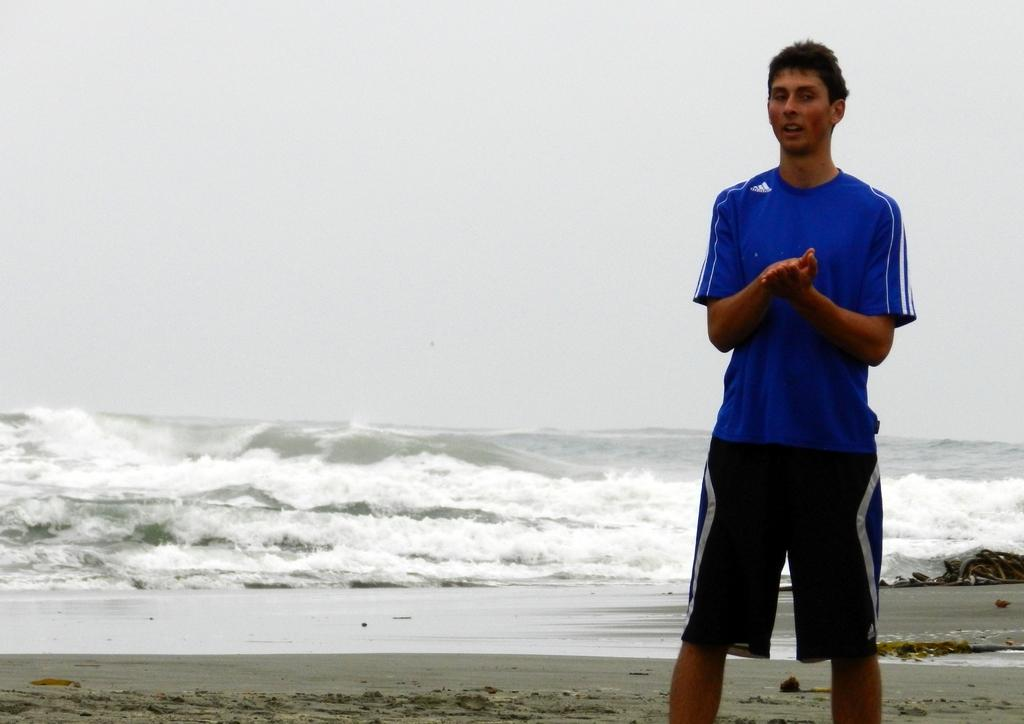What is the man doing in the image? The man is standing on the right side of the image. What can be seen on the sand in the image? There is an object on the sand. What type of terrain is visible in the background of the image? The background of the image includes sand. What else can be seen in the background of the image? Water and the sky are visible in the background of the image. How much money is the man holding in the image? The image does not show the man holding any money, so it cannot be determined from the image. 